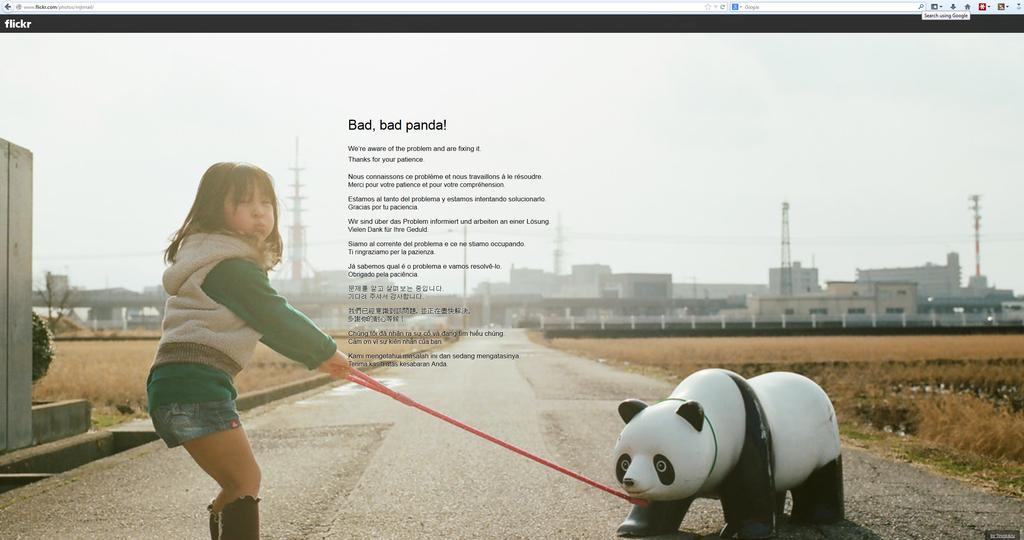What is the main subject of the image? The main subject of the image is a screen of a system. What is happening on the screen? A girl is standing on the screen. What is the girl holding in the image? The girl is holding a rope of toy pandas. What can be seen in the background of the image? Buildings, trees, and grass are visible in the background of the image. How many snails can be seen crawling on the girl's neck in the image? There are no snails visible in the image, nor is there any mention of snails in the image. 